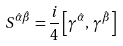Convert formula to latex. <formula><loc_0><loc_0><loc_500><loc_500>S ^ { \hat { \alpha } \hat { \beta } } = \frac { i } { 4 } \left [ \gamma ^ { \hat { \alpha } } , \, \gamma ^ { \hat { \beta } } \right ]</formula> 